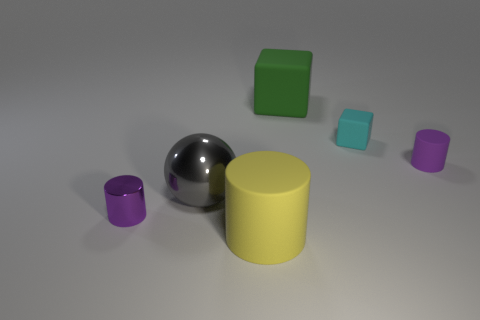Subtract 1 spheres. How many spheres are left? 0 Subtract all purple cylinders. How many cylinders are left? 1 Subtract all shiny cylinders. How many cylinders are left? 2 Subtract 1 yellow cylinders. How many objects are left? 5 Subtract all spheres. How many objects are left? 5 Subtract all purple balls. Subtract all purple blocks. How many balls are left? 1 Subtract all cyan spheres. How many green cylinders are left? 0 Subtract all rubber cylinders. Subtract all tiny rubber objects. How many objects are left? 2 Add 2 big green matte cubes. How many big green matte cubes are left? 3 Add 2 big gray spheres. How many big gray spheres exist? 3 